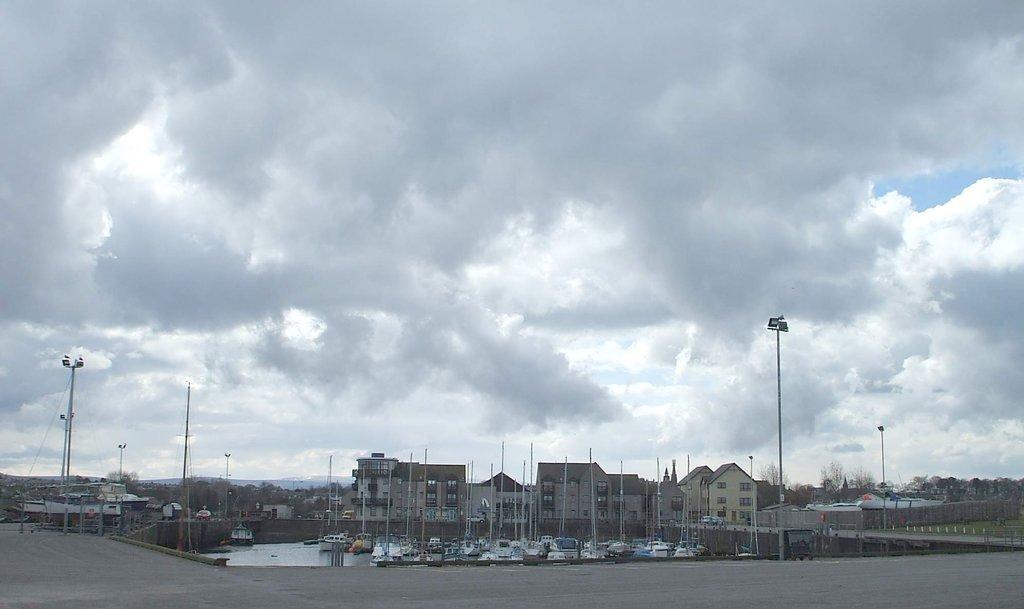Could you give a brief overview of what you see in this image? In this image we can see the houses, buildings, some poles, some lights with poles, some roads, some trees in the background, some wires with poles, some objects on the ground, one pond, some boats on the water, some poles attached to the boats, few vehicles on the roads, some grass on the ground, it looks like mountains in the background and at the top there is the sky. 